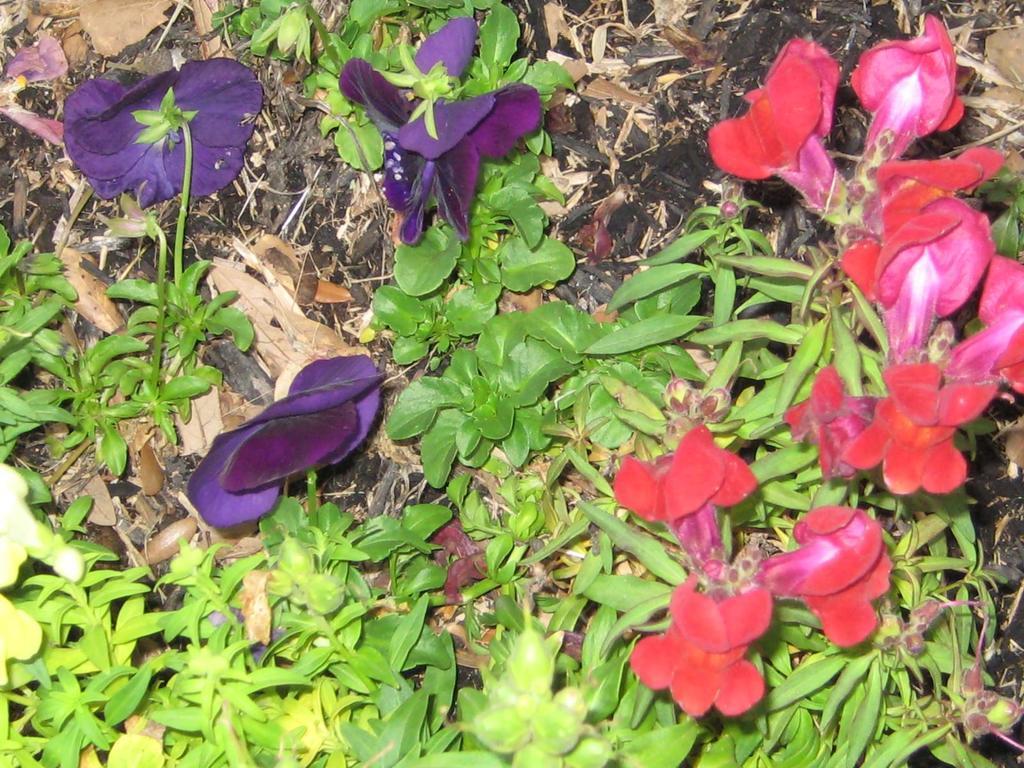What type of plants can be seen in the image? There are flowers in the image. What colors are the flowers in the image? The flowers are of pink, red, and violet colors. What else can be seen in the image besides the flowers? There are leaves in the image. What type of spark can be seen coming from the flowers in the image? There is no spark present in the image; it features flowers and leaves. How does the image affect the viewer's mind? The image's no information about the viewer's mind in the image, as it only contains flowers and leaves. 